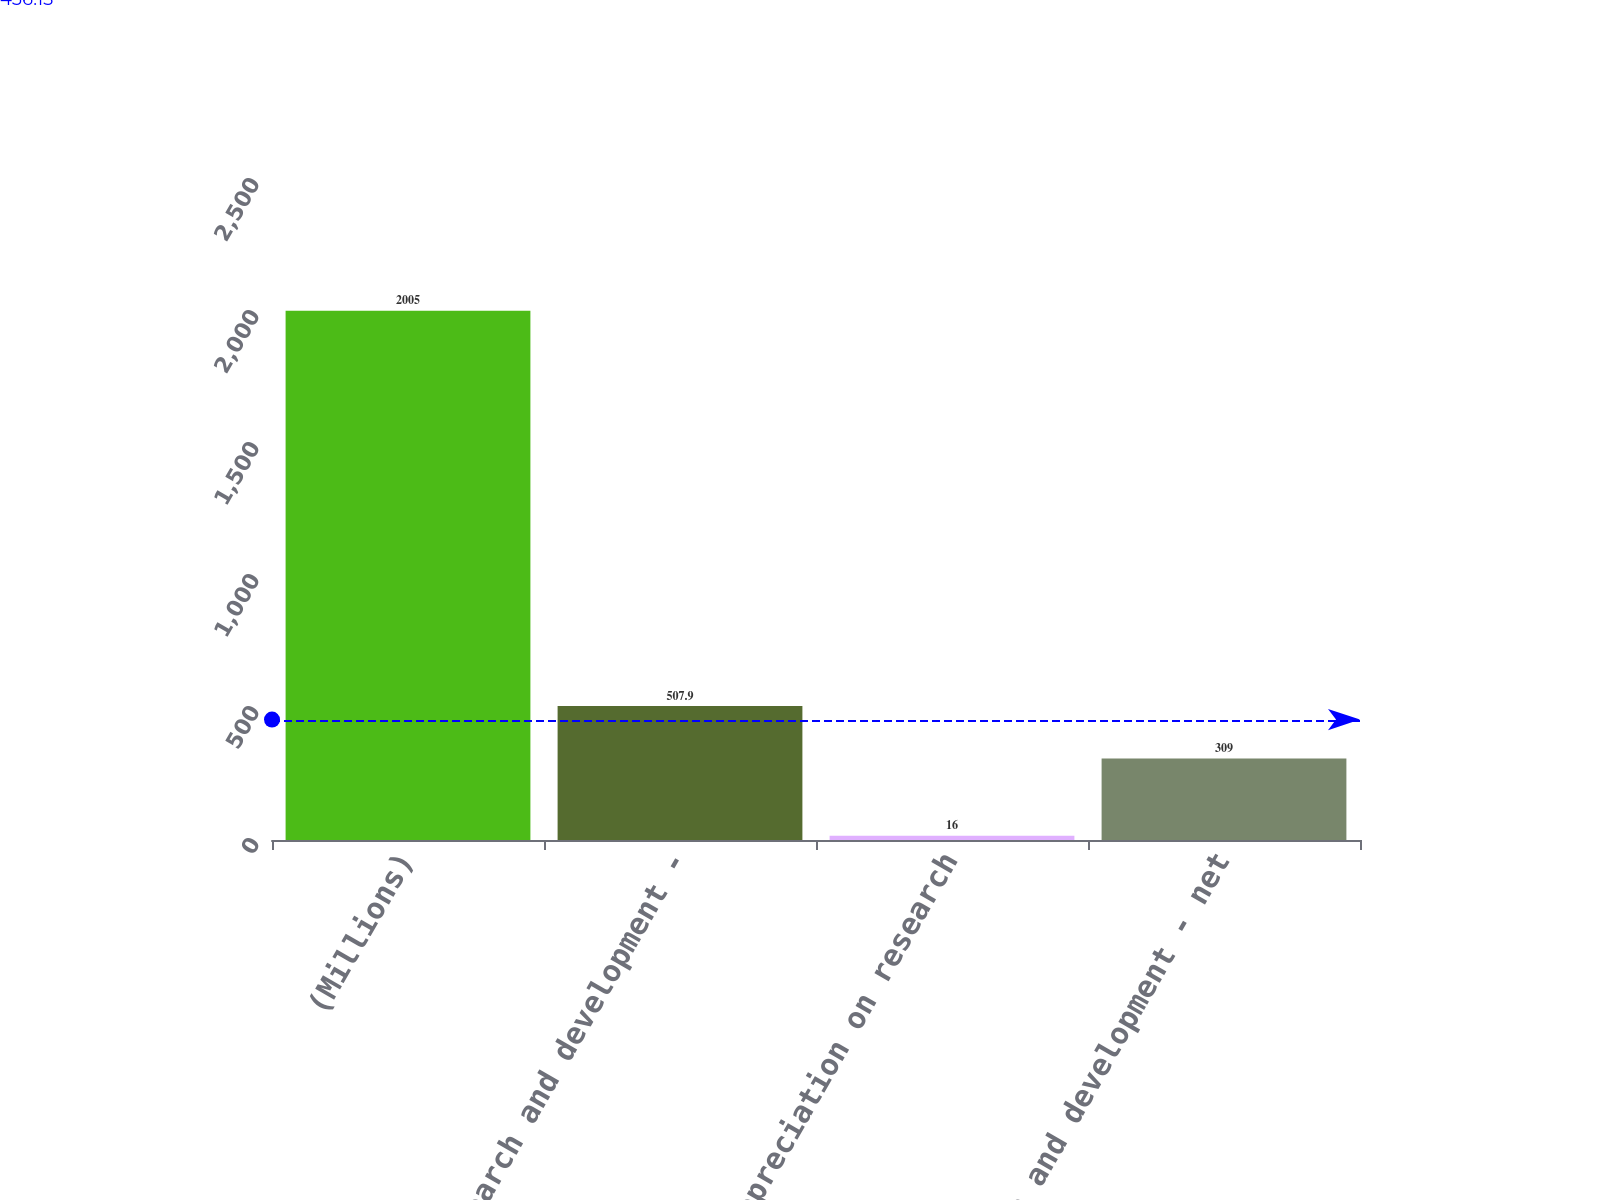Convert chart. <chart><loc_0><loc_0><loc_500><loc_500><bar_chart><fcel>(Millions)<fcel>Research and development -<fcel>Less depreciation on research<fcel>Research and development - net<nl><fcel>2005<fcel>507.9<fcel>16<fcel>309<nl></chart> 